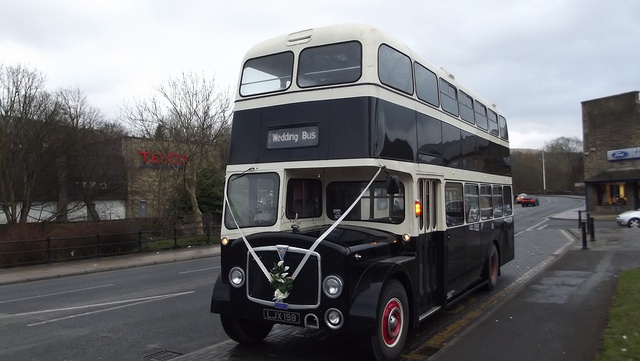Describe the objects in this image and their specific colors. I can see bus in white, black, gray, darkgray, and lightgray tones, car in white, gray, lightgray, black, and darkgray tones, car in white, black, gray, and maroon tones, and car in white, gray, darkgray, black, and brown tones in this image. 